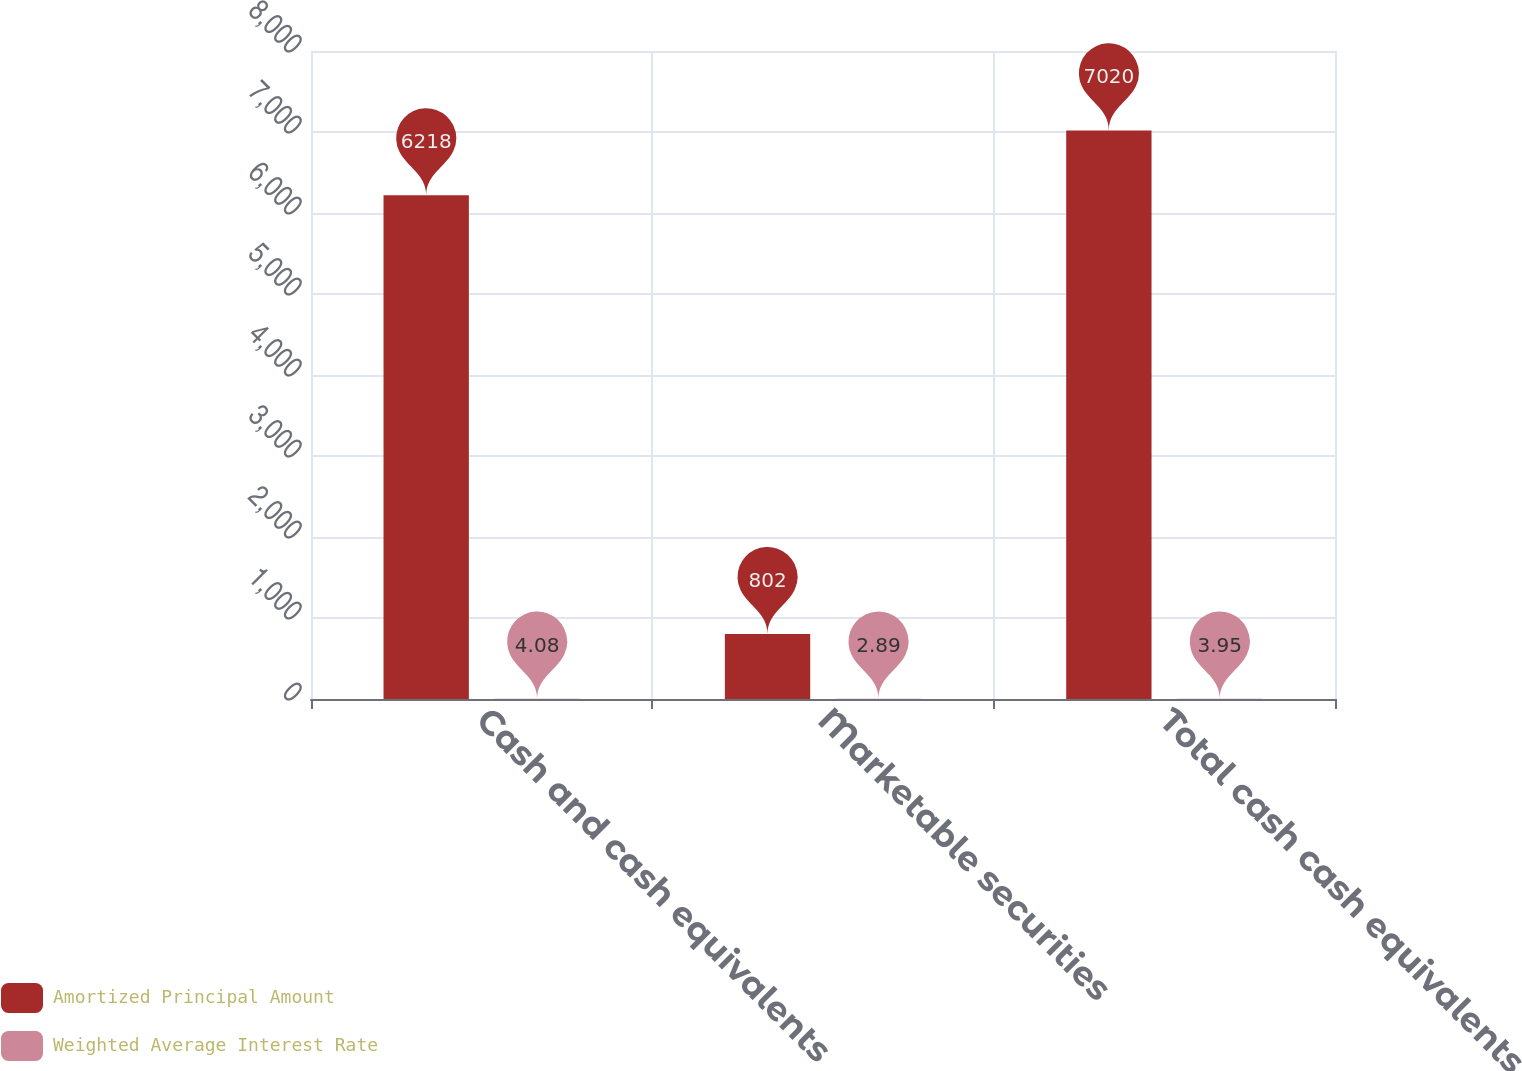<chart> <loc_0><loc_0><loc_500><loc_500><stacked_bar_chart><ecel><fcel>Cash and cash equivalents<fcel>Marketable securities<fcel>Total cash cash equivalents<nl><fcel>Amortized Principal Amount<fcel>6218<fcel>802<fcel>7020<nl><fcel>Weighted Average Interest Rate<fcel>4.08<fcel>2.89<fcel>3.95<nl></chart> 